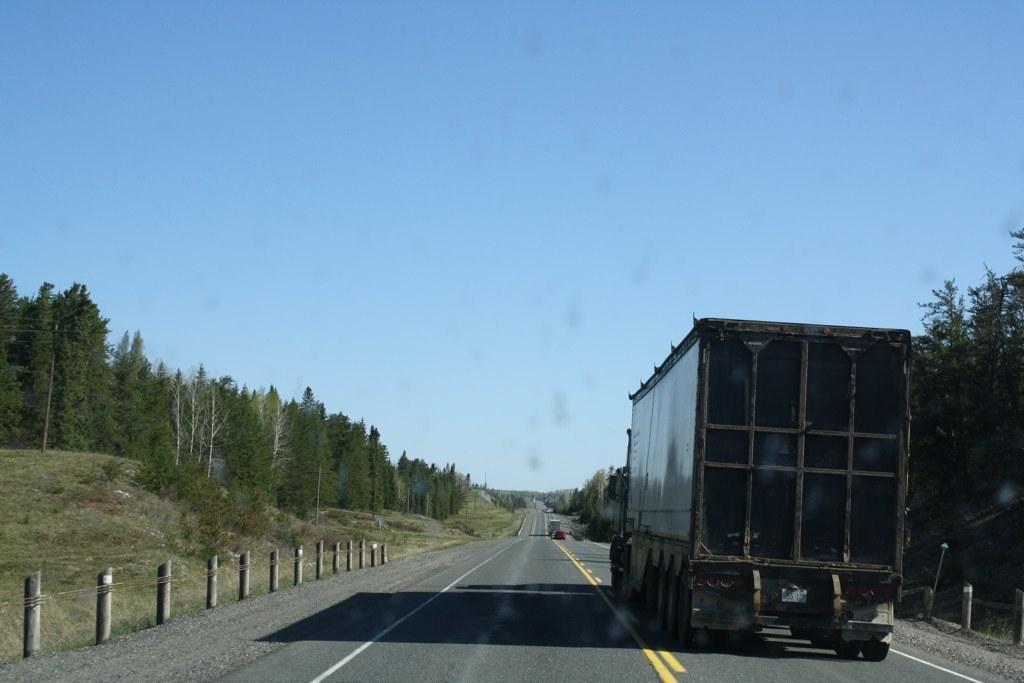Please provide a concise description of this image. In this image we can see some vehicles on the road and we can see the fence. There are some trees and grass on the ground and at the top we can see the sky. 